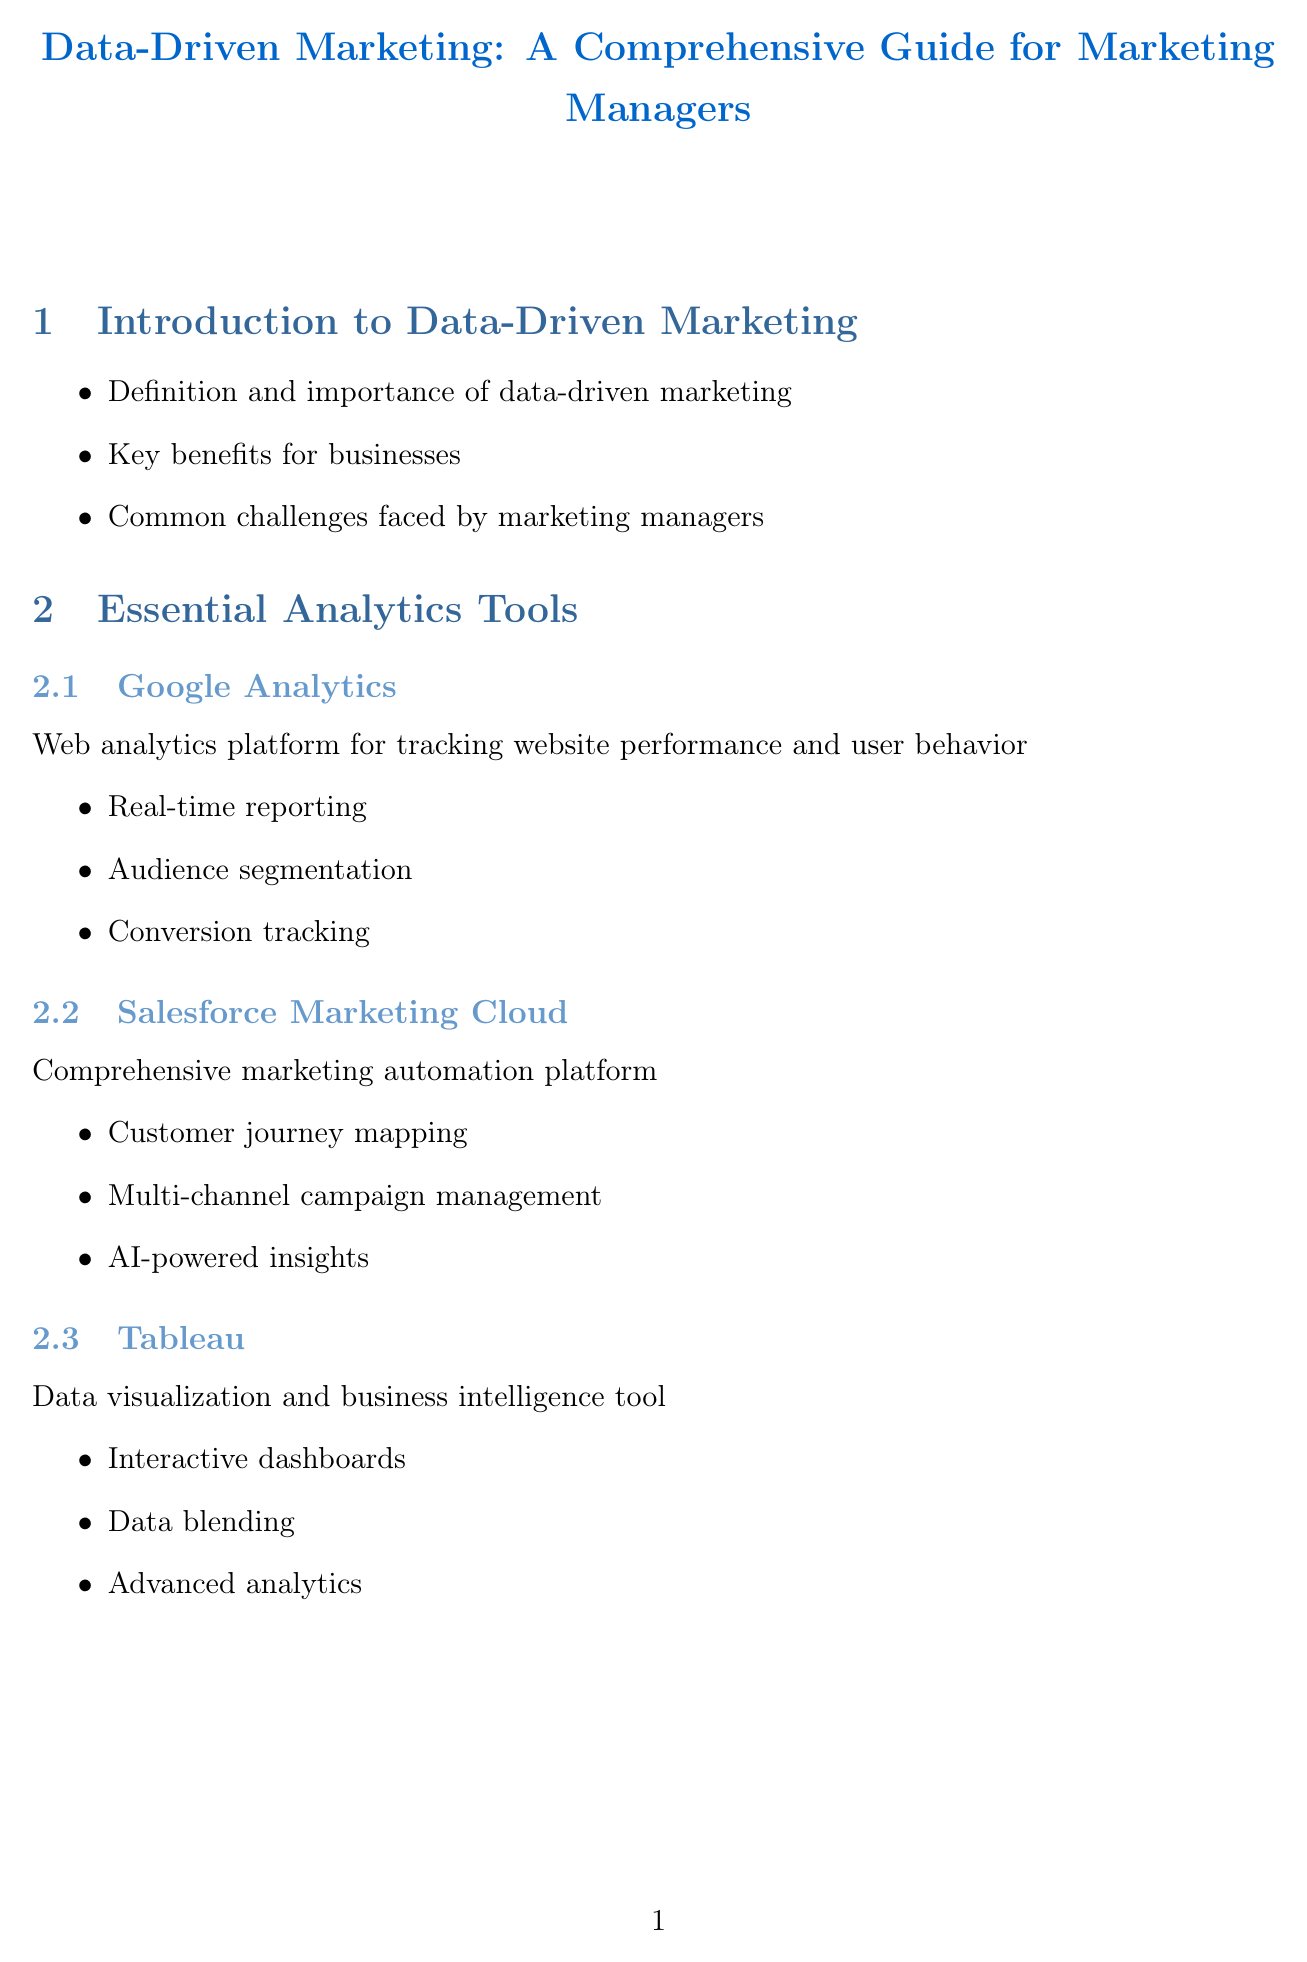What is the main focus of the document? The main focus of the document is data-driven marketing, which is aimed at marketing managers.
Answer: Data-driven marketing What analytics tool is used for tracking website performance? Google Analytics is specifically described as a web analytics platform for tracking website performance and user behavior.
Answer: Google Analytics What is Customer Acquisition Cost (CAC)? CAC is defined as the total cost of acquiring a new customer, with the calculation method provided in the document.
Answer: Total cost of acquiring a new customer Which company used personalized content recommendations? Netflix is cited as a company that implemented personalized content recommendations to increase user engagement.
Answer: Netflix What is one actionable insight for channel performance analysis? The document suggests reallocating budget to high-performing channels as an actionable insight for campaign optimization.
Answer: Reallocate budget to high-performing channels How many key features does Salesforce Marketing Cloud offer? Salesforce Marketing Cloud includes three key features listed in the document.
Answer: Three What plays a significant role in future data-driven marketing trends? Artificial intelligence is mentioned as a significant application in future trends.
Answer: Artificial Intelligence What does CLV stand for in marketing metrics? CLV stands for Customer Lifetime Value, which indicates the predicted net profit from an entire future relationship with a customer.
Answer: Customer Lifetime Value How can dynamic content be implemented according to the guide? The document suggests implementing dynamic content based on user behavior as a method for personalization.
Answer: Based on user behavior 